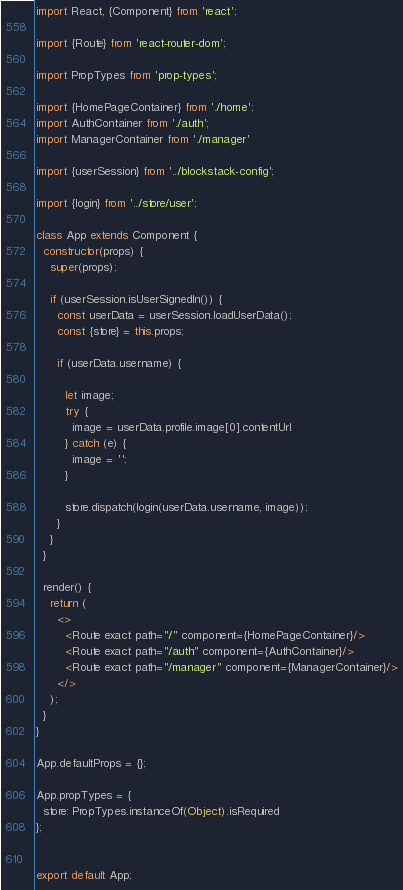Convert code to text. <code><loc_0><loc_0><loc_500><loc_500><_JavaScript_>import React, {Component} from 'react';

import {Route} from 'react-router-dom';

import PropTypes from 'prop-types';

import {HomePageContainer} from './home';
import AuthContainer from './auth';
import ManagerContainer from './manager'

import {userSession} from '../blockstack-config';

import {login} from '../store/user';

class App extends Component {
  constructor(props) {
    super(props);

    if (userSession.isUserSignedIn()) {
      const userData = userSession.loadUserData();
      const {store} = this.props;

      if (userData.username) {

        let image;
        try {
          image = userData.profile.image[0].contentUrl
        } catch (e) {
          image = '';
        }

        store.dispatch(login(userData.username, image));
      }
    }
  }

  render() {
    return (
      <>
        <Route exact path="/" component={HomePageContainer}/>
        <Route exact path="/auth" component={AuthContainer}/>
        <Route exact path="/manager" component={ManagerContainer}/>
      </>
    );
  }
}

App.defaultProps = {};

App.propTypes = {
  store: PropTypes.instanceOf(Object).isRequired
};


export default App;</code> 